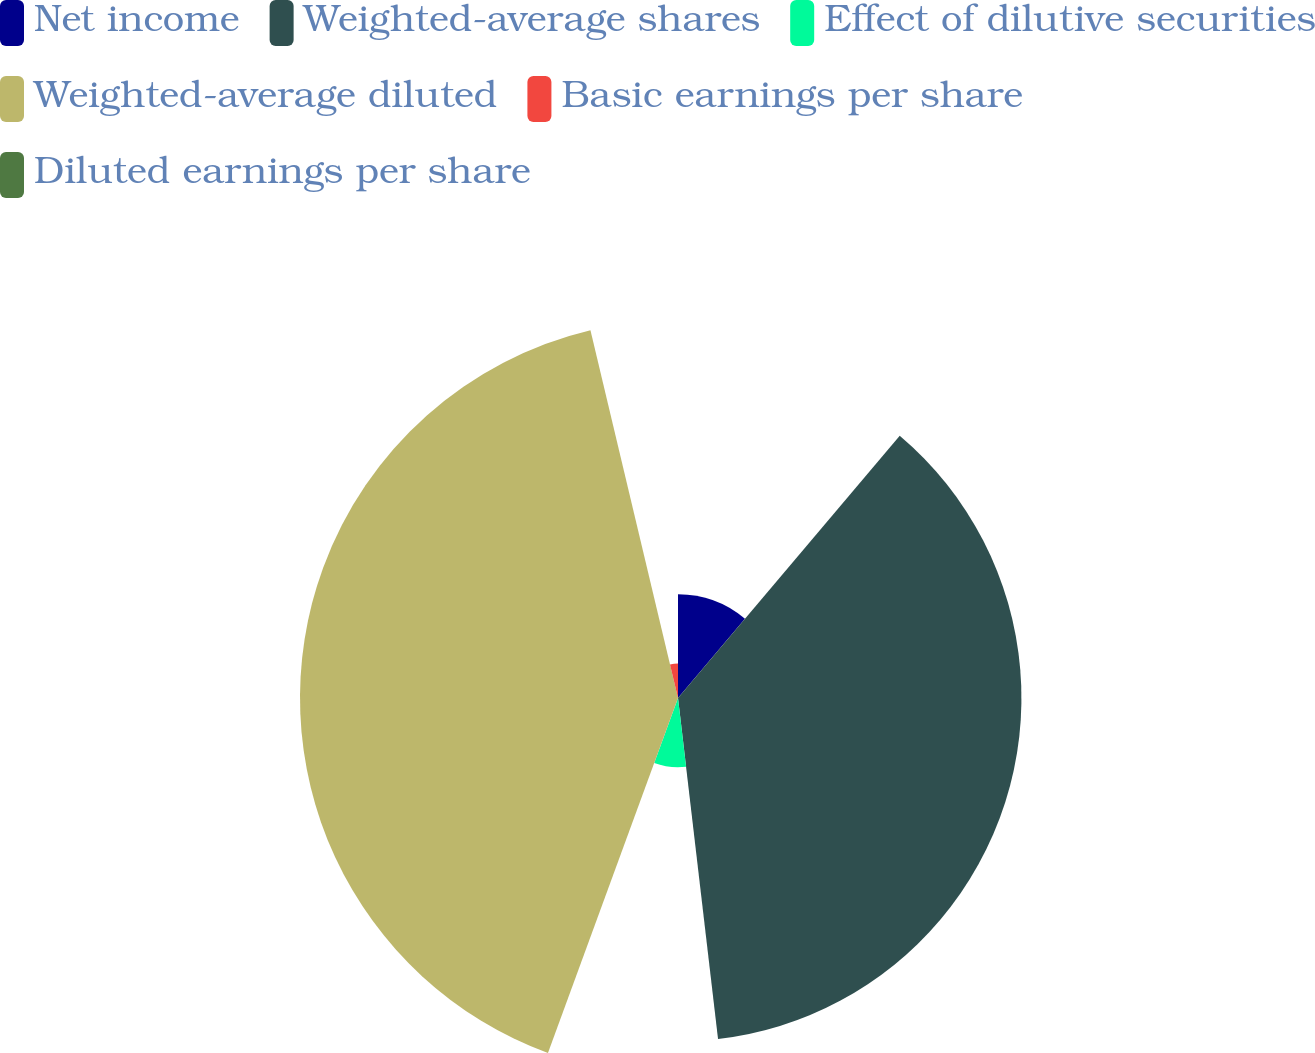Convert chart. <chart><loc_0><loc_0><loc_500><loc_500><pie_chart><fcel>Net income<fcel>Weighted-average shares<fcel>Effect of dilutive securities<fcel>Weighted-average diluted<fcel>Basic earnings per share<fcel>Diluted earnings per share<nl><fcel>11.17%<fcel>36.97%<fcel>7.45%<fcel>40.69%<fcel>3.72%<fcel>0.0%<nl></chart> 